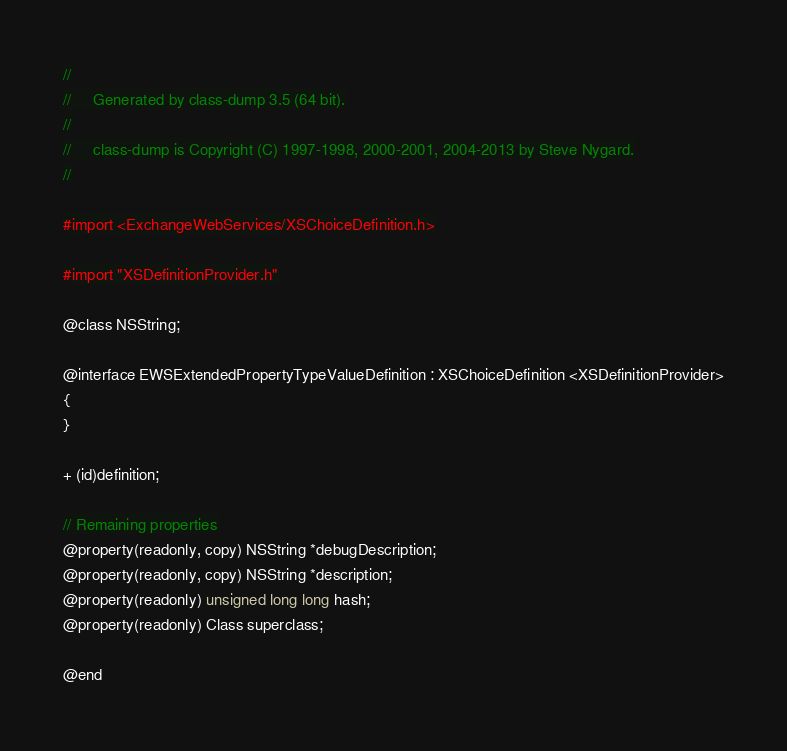Convert code to text. <code><loc_0><loc_0><loc_500><loc_500><_C_>//
//     Generated by class-dump 3.5 (64 bit).
//
//     class-dump is Copyright (C) 1997-1998, 2000-2001, 2004-2013 by Steve Nygard.
//

#import <ExchangeWebServices/XSChoiceDefinition.h>

#import "XSDefinitionProvider.h"

@class NSString;

@interface EWSExtendedPropertyTypeValueDefinition : XSChoiceDefinition <XSDefinitionProvider>
{
}

+ (id)definition;

// Remaining properties
@property(readonly, copy) NSString *debugDescription;
@property(readonly, copy) NSString *description;
@property(readonly) unsigned long long hash;
@property(readonly) Class superclass;

@end

</code> 